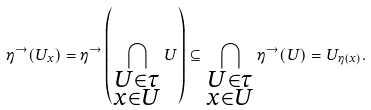Convert formula to latex. <formula><loc_0><loc_0><loc_500><loc_500>\eta ^ { \rightarrow } ( U _ { x } ) = \eta ^ { \rightarrow } \left ( \bigcap _ { \substack { U \in \tau \\ x \in U } } U \right ) \subseteq \bigcap _ { \substack { U \in \tau \\ x \in U } } \eta ^ { \rightarrow } ( U ) = U _ { \eta ( x ) } .</formula> 